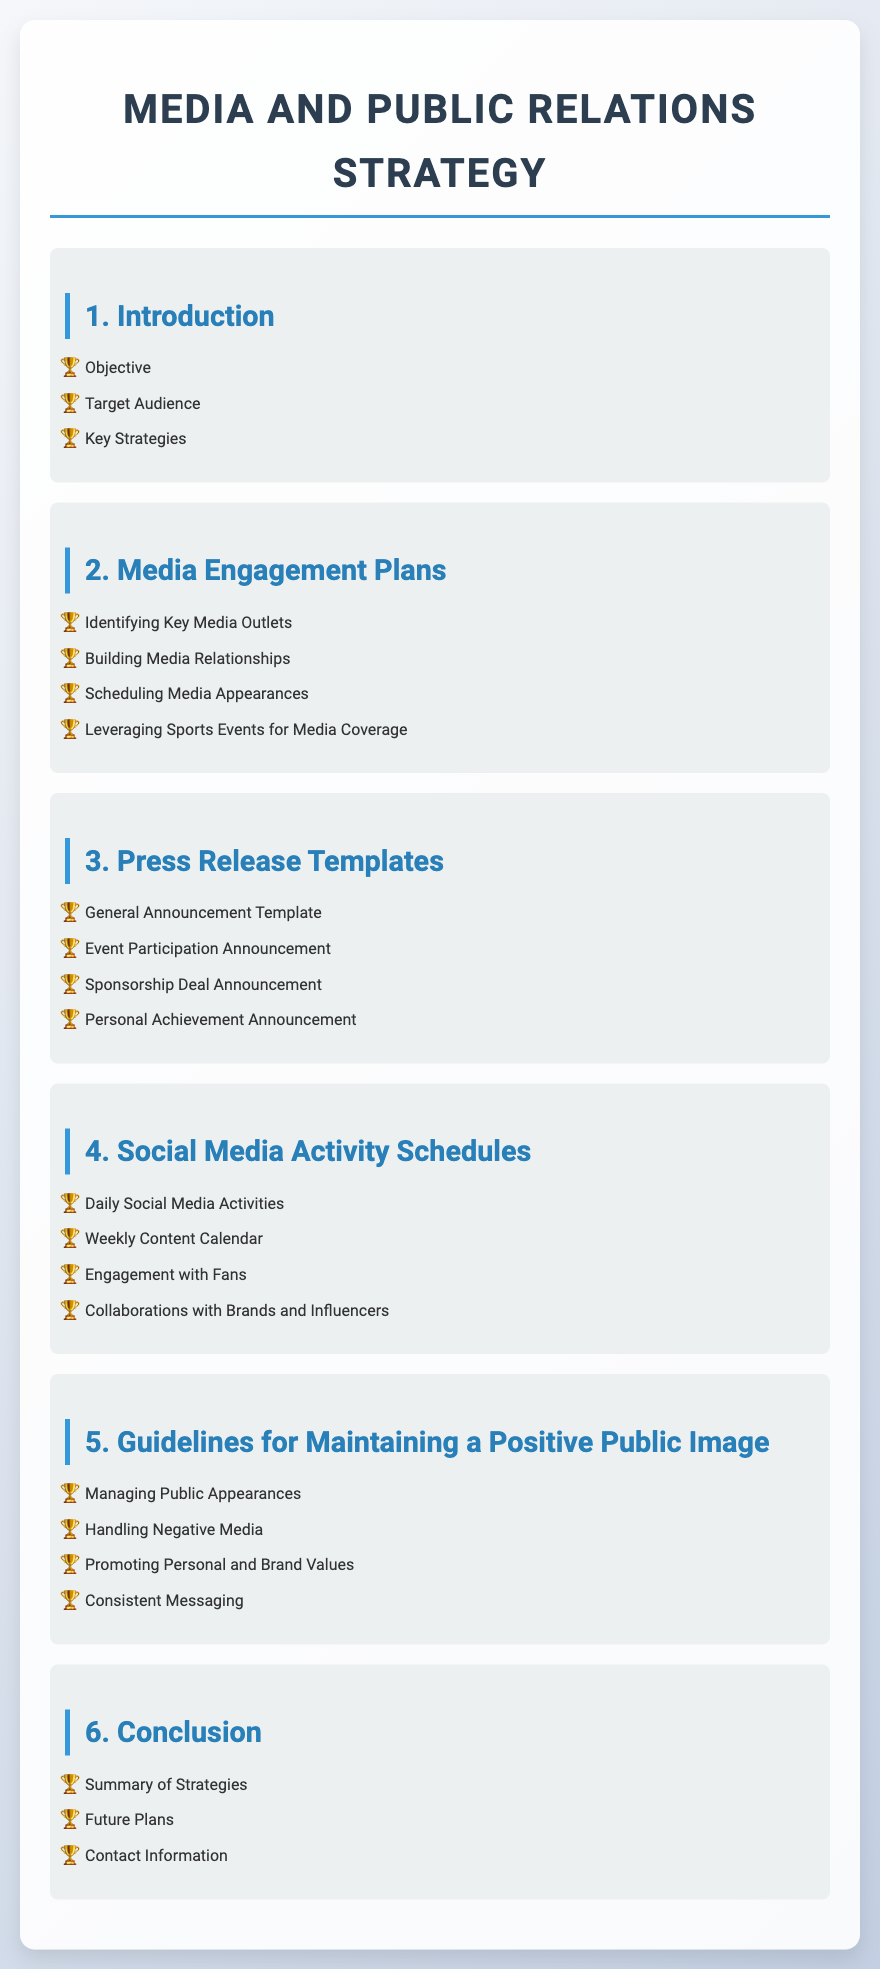What is the first section of the document? The first section in the document is labeled "1. Introduction."
Answer: 1. Introduction How many sections are there in total? There are six sections in the document as indicated in the Table of Contents.
Answer: 6 What is included in the Media Engagement Plans section? The Media Engagement Plans section includes four specific topics listed in the document.
Answer: Identifying Key Media Outlets, Building Media Relationships, Scheduling Media Appearances, Leveraging Sports Events for Media Coverage What type of announcement is included in the Press Release Templates? The Press Release Templates section includes four types of announcements.
Answer: Sponsorship Deal Announcement What is the focus of the fifth section? The fifth section focuses on maintaining a positive public image, as outlined in its title.
Answer: Guidelines for Maintaining a Positive Public Image What is one of the daily activities mentioned in the Social Media Activity Schedules? The Social Media Activity Schedules section lists several daily activities related to social media engagement.
Answer: Daily Social Media Activities What is the last item in the Conclusion section? The last item in the Conclusion section specifies what information is shared at the end of the document.
Answer: Contact Information 